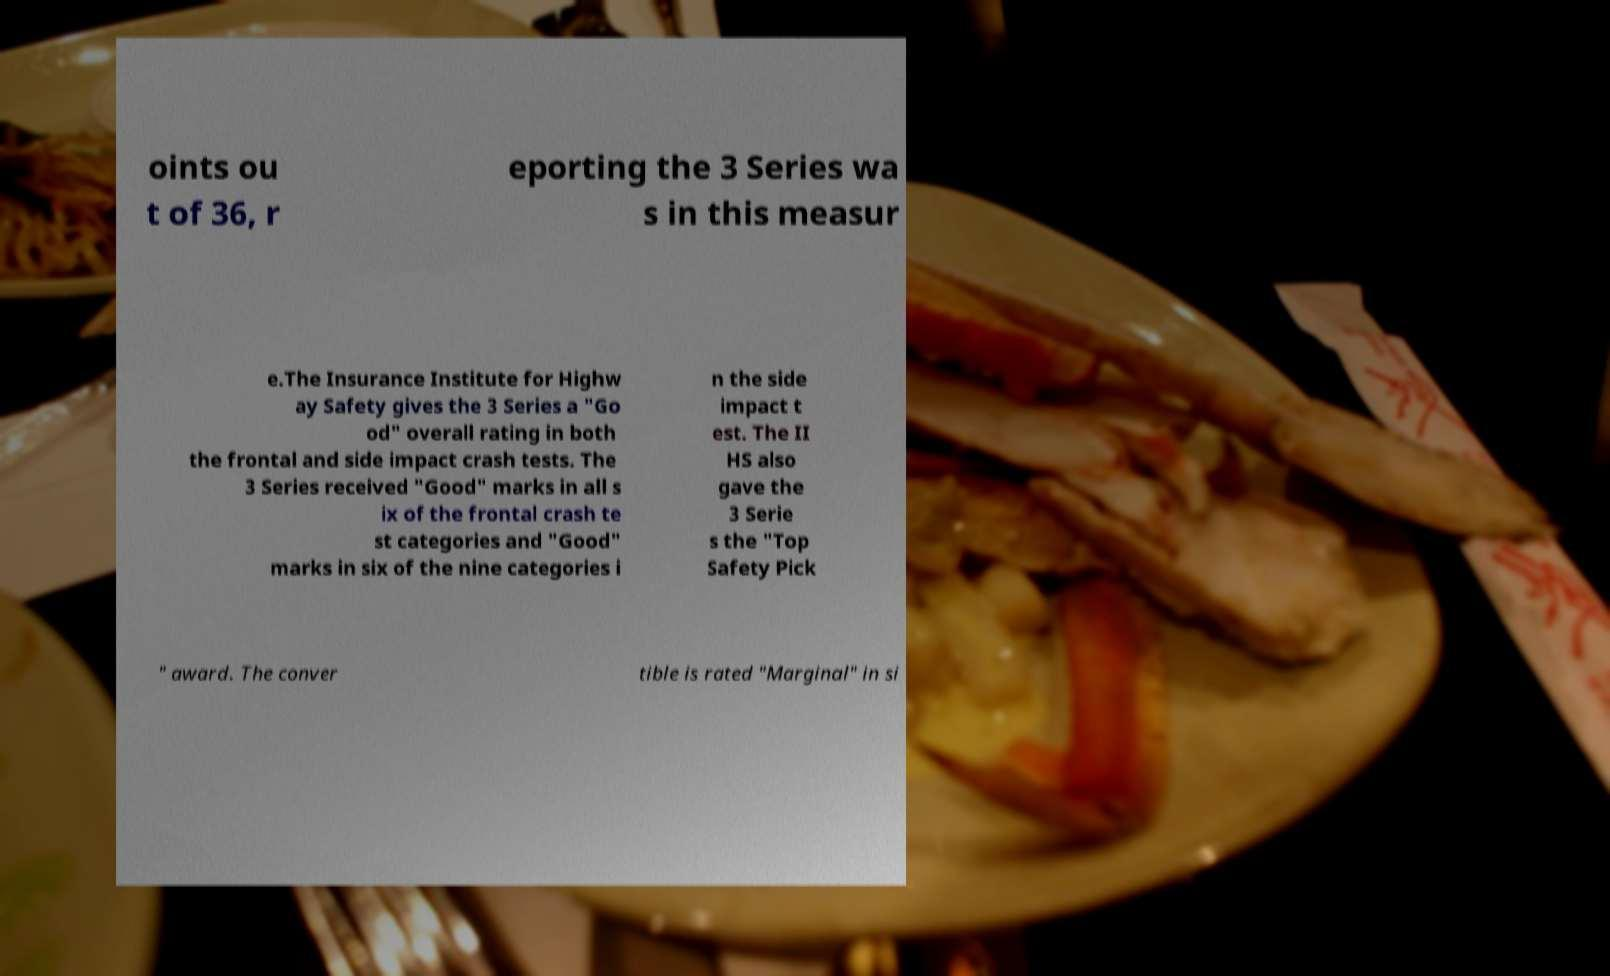What messages or text are displayed in this image? I need them in a readable, typed format. oints ou t of 36, r eporting the 3 Series wa s in this measur e.The Insurance Institute for Highw ay Safety gives the 3 Series a "Go od" overall rating in both the frontal and side impact crash tests. The 3 Series received "Good" marks in all s ix of the frontal crash te st categories and "Good" marks in six of the nine categories i n the side impact t est. The II HS also gave the 3 Serie s the "Top Safety Pick " award. The conver tible is rated "Marginal" in si 